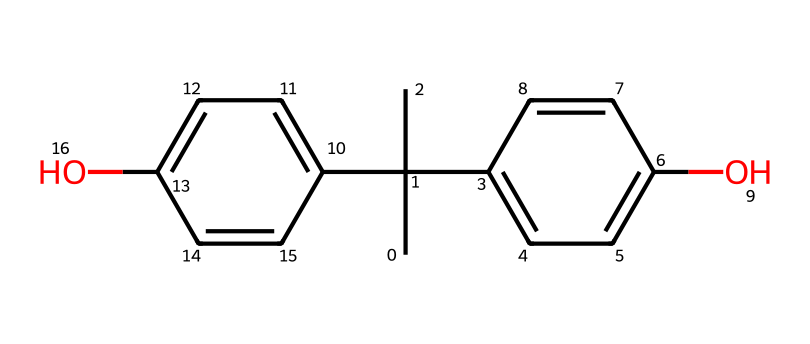What is the molecular formula of bisphenol A? By analyzing the SMILES representation provided, we can identify the different atoms present. The structure indicates that there are 15 carbon atoms (C), 16 hydrogen atoms (H), and 2 oxygen atoms (O). Combining these gives us the molecular formula C15H16O2.
Answer: C15H16O2 How many hydroxyl (–OH) groups are present in the structure? Upon examining the rendered chemical structure, we can see two hydroxyl groups (-OH) attached to aromatic rings in the molecule, indicating that there are 2 –OH groups present.
Answer: 2 What type of chemical is bisphenol A classified as? Bisphenol A is classified as a synthetic organic compound, specifically a phenol derivative due to the presence of hydroxyl groups on aromatic rings.
Answer: phenol What is the total number of aromatic rings in bisphenol A? In the 2D representation, we observe two distinct aromatic rings in the bisphenol A structure. These are indicated by the cyclic arrangement of carbon atoms alternating with double bonds (denoted in the benzene rings).
Answer: 2 Which property makes bisphenol A a toxic chemical? BPA is known for its endocrine-disrupting properties, primarily due to its ability to mimic estrogen. This mimicking activity arises from the molecular structure that allows it to bind to estrogen receptors.
Answer: endocrine disruptor 